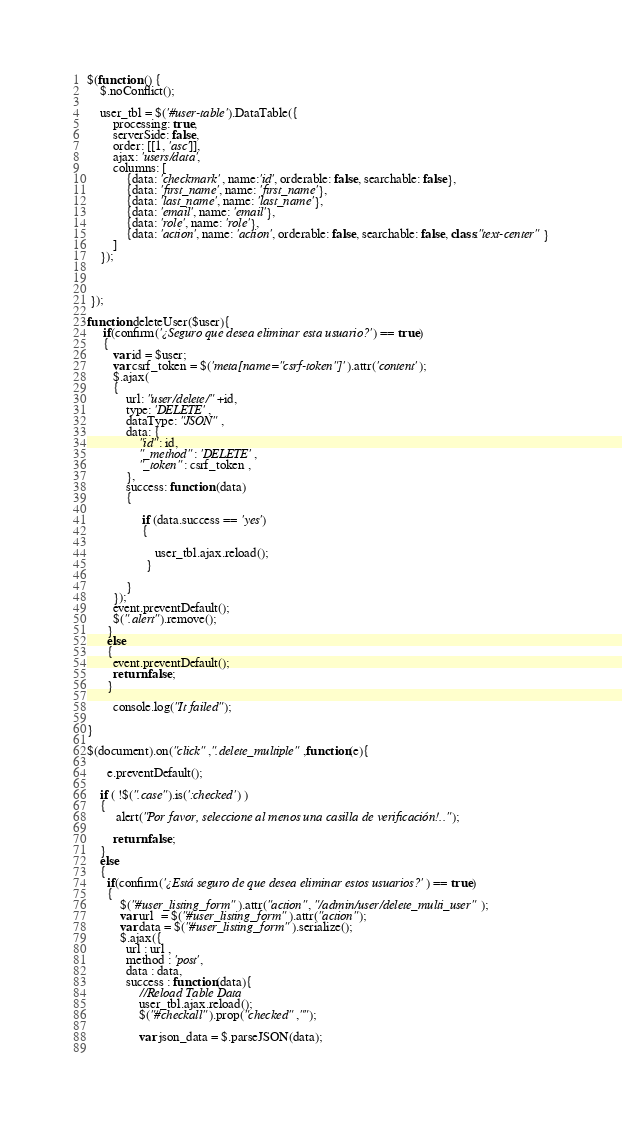<code> <loc_0><loc_0><loc_500><loc_500><_JavaScript_>$(function () {
  	$.noConflict();

    user_tbl = $('#user-table').DataTable({
        processing: true,
        serverSide: false,
        order: [[1, 'asc']],
        ajax: 'users/data',
        columns: [
            {data: 'checkmark', name:'id', orderable: false, searchable: false},
            {data: 'first_name', name: 'first_name'},
            {data: 'last_name', name: 'last_name'},
            {data: 'email', name: 'email'},
            {data: 'role', name: 'role'},
            {data: 'action', name: 'action', orderable: false, searchable: false, class:"text-center"}
        ]
    });
  
    

 });

function deleteUser($user){
     if(confirm('¿Seguro que desea eliminar esta usuario?') == true)
     {
        var id = $user;
        var csrf_token = $('meta[name="csrf-token"]').attr('content');
        $.ajax(
        {
            url: "user/delete/"+id,
            type: 'DELETE',
            dataType: "JSON",
            data: {
                "id": id,
                "_method": 'DELETE',
                "_token": csrf_token ,
            },
            success: function (data)
            {

                 if (data.success == 'yes')
                 {
                    
                     user_tbl.ajax.reload();
                  }
                  
            }
        });
        event.preventDefault();
        $(".alert").remove();
      }
      else
      {
        event.preventDefault();
        return false;
      }  

        console.log("It failed");

}  

$(document).on("click",".delete_multiple",function(e){
      
      e.preventDefault();
      
    if ( !$(".case").is(':checked') )
    {
         alert("Por favor, seleccione al menos una casilla de verificación!..");
        
        return false; 
    }
    else
    {
      if(confirm('¿Está seguro de que desea eliminar estos usuarios?') == true)
      {
          $("#user_listing_form").attr("action", "/admin/user/delete_multi_user");
          var url  = $("#user_listing_form").attr("action");
          var data = $("#user_listing_form").serialize();
          $.ajax({
            url : url ,
            method : 'post',
            data : data,
            success : function(data){
                //Reload Table Data 
                user_tbl.ajax.reload();
                $("#checkall").prop("checked","");
                
                var json_data = $.parseJSON(data);
              </code> 